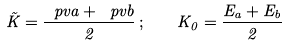<formula> <loc_0><loc_0><loc_500><loc_500>\vec { K } = \frac { \ p v a + \ p v b } { 2 } \, ; \quad K _ { 0 } = \frac { E _ { a } + E _ { b } } { 2 }</formula> 